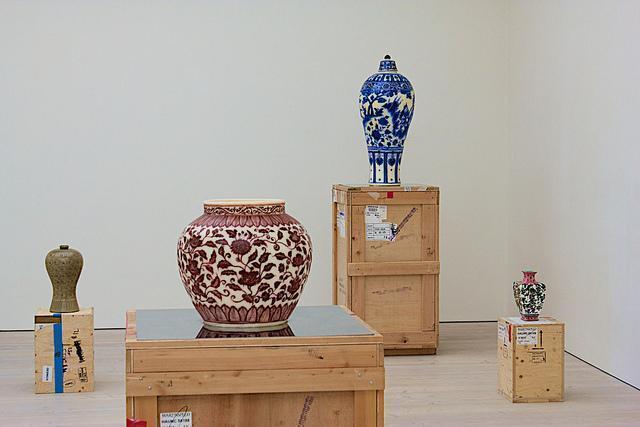What is the main color of the Chinese vase on the center right?
Make your selection from the four choices given to correctly answer the question.
Options: Red, blue, green, yellow. Blue. 